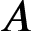Convert formula to latex. <formula><loc_0><loc_0><loc_500><loc_500>A</formula> 